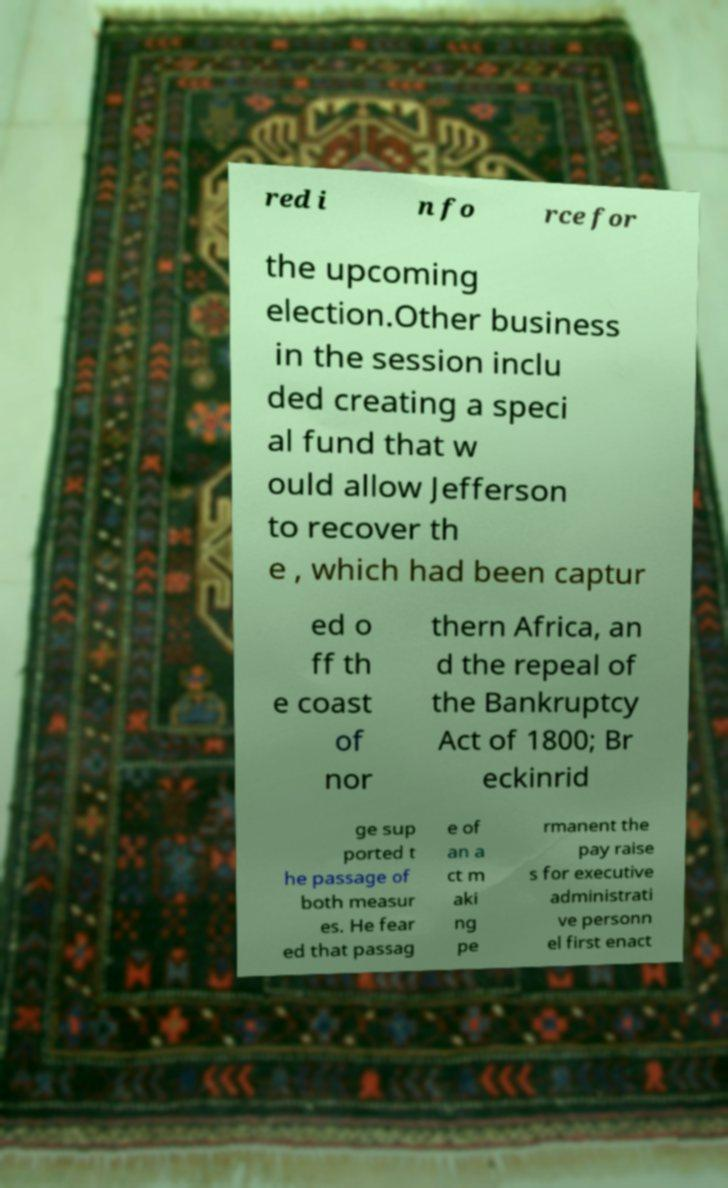Please identify and transcribe the text found in this image. red i n fo rce for the upcoming election.Other business in the session inclu ded creating a speci al fund that w ould allow Jefferson to recover th e , which had been captur ed o ff th e coast of nor thern Africa, an d the repeal of the Bankruptcy Act of 1800; Br eckinrid ge sup ported t he passage of both measur es. He fear ed that passag e of an a ct m aki ng pe rmanent the pay raise s for executive administrati ve personn el first enact 